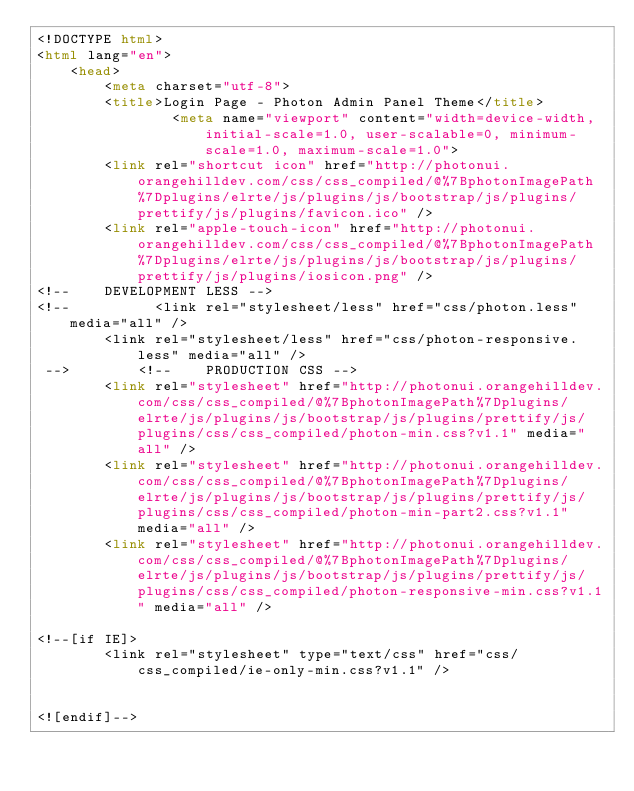<code> <loc_0><loc_0><loc_500><loc_500><_HTML_><!DOCTYPE html>
<html lang="en">
    <head>
        <meta charset="utf-8">
        <title>Login Page - Photon Admin Panel Theme</title>
                <meta name="viewport" content="width=device-width, initial-scale=1.0, user-scalable=0, minimum-scale=1.0, maximum-scale=1.0">
        <link rel="shortcut icon" href="http://photonui.orangehilldev.com/css/css_compiled/@%7BphotonImagePath%7Dplugins/elrte/js/plugins/js/bootstrap/js/plugins/prettify/js/plugins/favicon.ico" />
        <link rel="apple-touch-icon" href="http://photonui.orangehilldev.com/css/css_compiled/@%7BphotonImagePath%7Dplugins/elrte/js/plugins/js/bootstrap/js/plugins/prettify/js/plugins/iosicon.png" />
<!--    DEVELOPMENT LESS -->
<!--          <link rel="stylesheet/less" href="css/photon.less" media="all" />
        <link rel="stylesheet/less" href="css/photon-responsive.less" media="all" />
 -->        <!--    PRODUCTION CSS -->
        <link rel="stylesheet" href="http://photonui.orangehilldev.com/css/css_compiled/@%7BphotonImagePath%7Dplugins/elrte/js/plugins/js/bootstrap/js/plugins/prettify/js/plugins/css/css_compiled/photon-min.css?v1.1" media="all" />
        <link rel="stylesheet" href="http://photonui.orangehilldev.com/css/css_compiled/@%7BphotonImagePath%7Dplugins/elrte/js/plugins/js/bootstrap/js/plugins/prettify/js/plugins/css/css_compiled/photon-min-part2.css?v1.1" media="all" />
        <link rel="stylesheet" href="http://photonui.orangehilldev.com/css/css_compiled/@%7BphotonImagePath%7Dplugins/elrte/js/plugins/js/bootstrap/js/plugins/prettify/js/plugins/css/css_compiled/photon-responsive-min.css?v1.1" media="all" />

<!--[if IE]>
        <link rel="stylesheet" type="text/css" href="css/css_compiled/ie-only-min.css?v1.1" />
        

<![endif]-->
</code> 